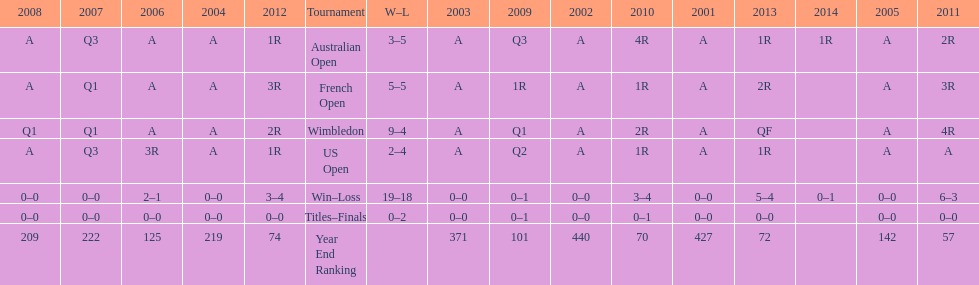What was this players ranking after 2005? 125. 